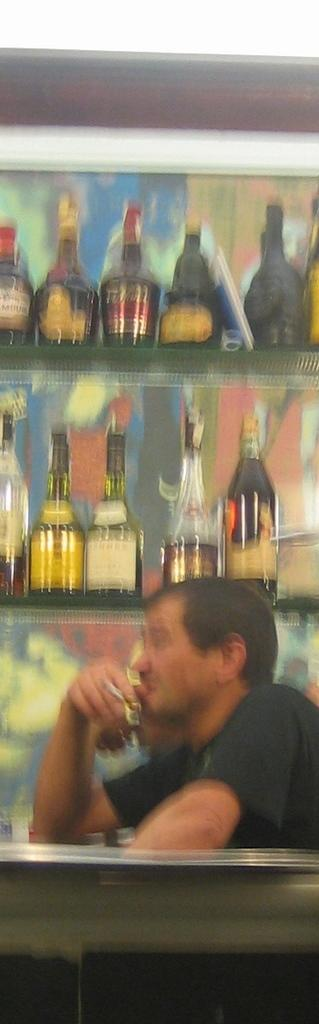What is the man in the image doing? The man is sitting in the image. What is the man holding in the image? The man is holding a glass in the image. What else can be seen in the image besides the man? There are bottles in the image. How are the bottles arranged in the image? The bottles are kept in rocks in the image. What is the color of the rocks? The rocks are black in color. What type of grape is the man eating in the image? There is no grape present in the image. 